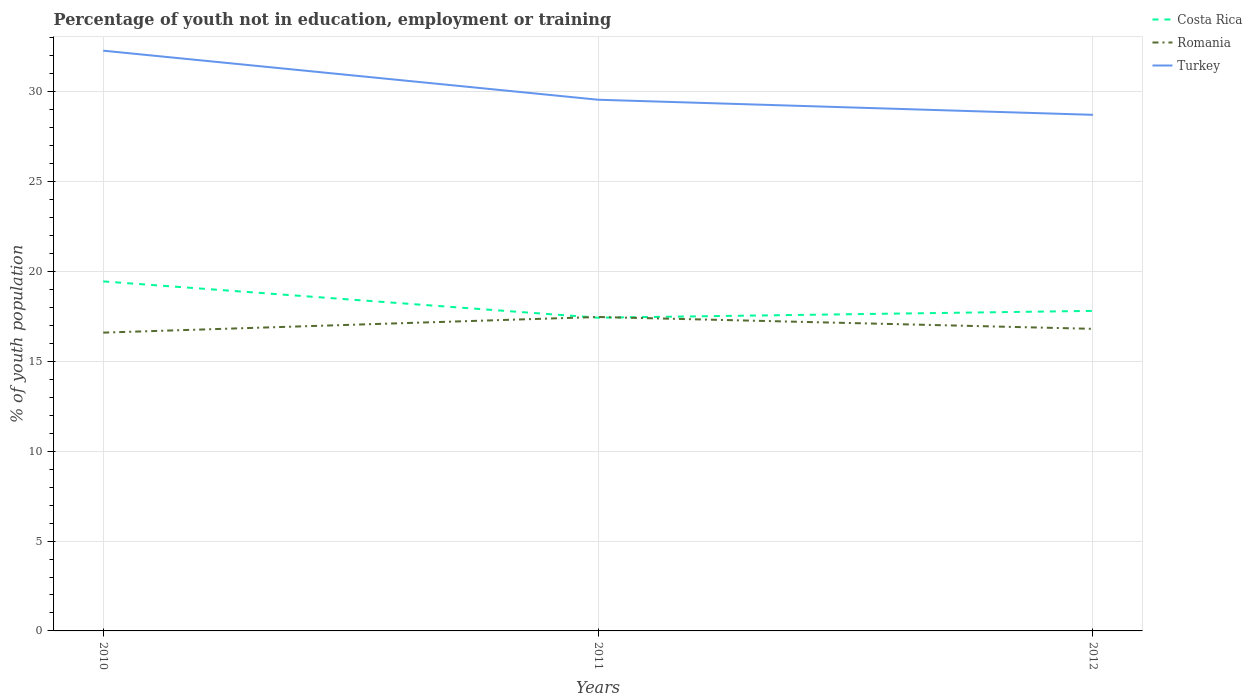Across all years, what is the maximum percentage of unemployed youth population in in Costa Rica?
Your response must be concise. 17.43. In which year was the percentage of unemployed youth population in in Romania maximum?
Your response must be concise. 2010. What is the total percentage of unemployed youth population in in Romania in the graph?
Provide a succinct answer. -0.87. What is the difference between the highest and the second highest percentage of unemployed youth population in in Romania?
Give a very brief answer. 0.87. How many lines are there?
Provide a succinct answer. 3. Are the values on the major ticks of Y-axis written in scientific E-notation?
Offer a terse response. No. Does the graph contain any zero values?
Ensure brevity in your answer.  No. Does the graph contain grids?
Provide a short and direct response. Yes. Where does the legend appear in the graph?
Make the answer very short. Top right. How many legend labels are there?
Provide a succinct answer. 3. How are the legend labels stacked?
Provide a short and direct response. Vertical. What is the title of the graph?
Provide a short and direct response. Percentage of youth not in education, employment or training. Does "Heavily indebted poor countries" appear as one of the legend labels in the graph?
Provide a succinct answer. No. What is the label or title of the Y-axis?
Offer a terse response. % of youth population. What is the % of youth population of Costa Rica in 2010?
Offer a terse response. 19.45. What is the % of youth population of Romania in 2010?
Keep it short and to the point. 16.6. What is the % of youth population of Turkey in 2010?
Provide a succinct answer. 32.29. What is the % of youth population of Costa Rica in 2011?
Offer a very short reply. 17.43. What is the % of youth population in Romania in 2011?
Give a very brief answer. 17.47. What is the % of youth population in Turkey in 2011?
Offer a very short reply. 29.56. What is the % of youth population of Costa Rica in 2012?
Keep it short and to the point. 17.81. What is the % of youth population in Romania in 2012?
Provide a short and direct response. 16.81. What is the % of youth population in Turkey in 2012?
Give a very brief answer. 28.72. Across all years, what is the maximum % of youth population of Costa Rica?
Your answer should be compact. 19.45. Across all years, what is the maximum % of youth population in Romania?
Ensure brevity in your answer.  17.47. Across all years, what is the maximum % of youth population of Turkey?
Keep it short and to the point. 32.29. Across all years, what is the minimum % of youth population in Costa Rica?
Give a very brief answer. 17.43. Across all years, what is the minimum % of youth population of Romania?
Your answer should be compact. 16.6. Across all years, what is the minimum % of youth population of Turkey?
Make the answer very short. 28.72. What is the total % of youth population in Costa Rica in the graph?
Offer a terse response. 54.69. What is the total % of youth population in Romania in the graph?
Provide a short and direct response. 50.88. What is the total % of youth population in Turkey in the graph?
Offer a very short reply. 90.57. What is the difference between the % of youth population in Costa Rica in 2010 and that in 2011?
Offer a very short reply. 2.02. What is the difference between the % of youth population of Romania in 2010 and that in 2011?
Provide a short and direct response. -0.87. What is the difference between the % of youth population of Turkey in 2010 and that in 2011?
Offer a terse response. 2.73. What is the difference between the % of youth population of Costa Rica in 2010 and that in 2012?
Keep it short and to the point. 1.64. What is the difference between the % of youth population of Romania in 2010 and that in 2012?
Ensure brevity in your answer.  -0.21. What is the difference between the % of youth population in Turkey in 2010 and that in 2012?
Offer a terse response. 3.57. What is the difference between the % of youth population of Costa Rica in 2011 and that in 2012?
Provide a succinct answer. -0.38. What is the difference between the % of youth population of Romania in 2011 and that in 2012?
Ensure brevity in your answer.  0.66. What is the difference between the % of youth population of Turkey in 2011 and that in 2012?
Your answer should be compact. 0.84. What is the difference between the % of youth population in Costa Rica in 2010 and the % of youth population in Romania in 2011?
Offer a terse response. 1.98. What is the difference between the % of youth population in Costa Rica in 2010 and the % of youth population in Turkey in 2011?
Ensure brevity in your answer.  -10.11. What is the difference between the % of youth population of Romania in 2010 and the % of youth population of Turkey in 2011?
Give a very brief answer. -12.96. What is the difference between the % of youth population of Costa Rica in 2010 and the % of youth population of Romania in 2012?
Provide a succinct answer. 2.64. What is the difference between the % of youth population of Costa Rica in 2010 and the % of youth population of Turkey in 2012?
Your answer should be very brief. -9.27. What is the difference between the % of youth population in Romania in 2010 and the % of youth population in Turkey in 2012?
Give a very brief answer. -12.12. What is the difference between the % of youth population in Costa Rica in 2011 and the % of youth population in Romania in 2012?
Give a very brief answer. 0.62. What is the difference between the % of youth population in Costa Rica in 2011 and the % of youth population in Turkey in 2012?
Provide a short and direct response. -11.29. What is the difference between the % of youth population of Romania in 2011 and the % of youth population of Turkey in 2012?
Your response must be concise. -11.25. What is the average % of youth population in Costa Rica per year?
Your response must be concise. 18.23. What is the average % of youth population of Romania per year?
Provide a short and direct response. 16.96. What is the average % of youth population in Turkey per year?
Provide a succinct answer. 30.19. In the year 2010, what is the difference between the % of youth population of Costa Rica and % of youth population of Romania?
Make the answer very short. 2.85. In the year 2010, what is the difference between the % of youth population of Costa Rica and % of youth population of Turkey?
Offer a very short reply. -12.84. In the year 2010, what is the difference between the % of youth population of Romania and % of youth population of Turkey?
Your response must be concise. -15.69. In the year 2011, what is the difference between the % of youth population of Costa Rica and % of youth population of Romania?
Your response must be concise. -0.04. In the year 2011, what is the difference between the % of youth population in Costa Rica and % of youth population in Turkey?
Your response must be concise. -12.13. In the year 2011, what is the difference between the % of youth population of Romania and % of youth population of Turkey?
Provide a short and direct response. -12.09. In the year 2012, what is the difference between the % of youth population of Costa Rica and % of youth population of Turkey?
Provide a short and direct response. -10.91. In the year 2012, what is the difference between the % of youth population in Romania and % of youth population in Turkey?
Provide a short and direct response. -11.91. What is the ratio of the % of youth population in Costa Rica in 2010 to that in 2011?
Make the answer very short. 1.12. What is the ratio of the % of youth population in Romania in 2010 to that in 2011?
Your answer should be very brief. 0.95. What is the ratio of the % of youth population of Turkey in 2010 to that in 2011?
Offer a very short reply. 1.09. What is the ratio of the % of youth population in Costa Rica in 2010 to that in 2012?
Keep it short and to the point. 1.09. What is the ratio of the % of youth population of Romania in 2010 to that in 2012?
Make the answer very short. 0.99. What is the ratio of the % of youth population of Turkey in 2010 to that in 2012?
Make the answer very short. 1.12. What is the ratio of the % of youth population in Costa Rica in 2011 to that in 2012?
Offer a terse response. 0.98. What is the ratio of the % of youth population in Romania in 2011 to that in 2012?
Your answer should be very brief. 1.04. What is the ratio of the % of youth population in Turkey in 2011 to that in 2012?
Offer a very short reply. 1.03. What is the difference between the highest and the second highest % of youth population of Costa Rica?
Offer a terse response. 1.64. What is the difference between the highest and the second highest % of youth population of Romania?
Give a very brief answer. 0.66. What is the difference between the highest and the second highest % of youth population in Turkey?
Offer a very short reply. 2.73. What is the difference between the highest and the lowest % of youth population in Costa Rica?
Offer a terse response. 2.02. What is the difference between the highest and the lowest % of youth population of Romania?
Give a very brief answer. 0.87. What is the difference between the highest and the lowest % of youth population in Turkey?
Offer a terse response. 3.57. 